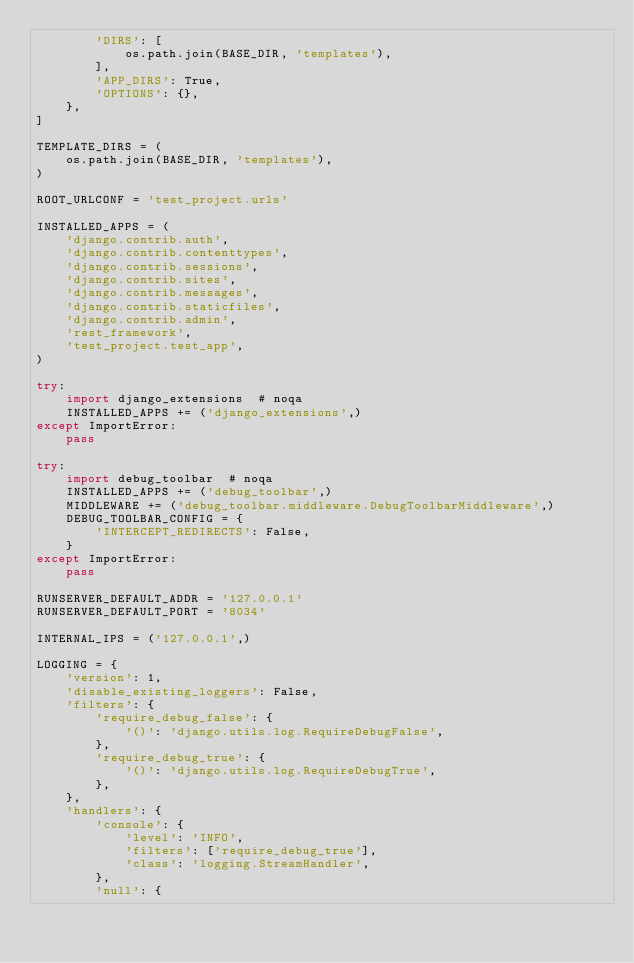Convert code to text. <code><loc_0><loc_0><loc_500><loc_500><_Python_>        'DIRS': [
            os.path.join(BASE_DIR, 'templates'),
        ],
        'APP_DIRS': True,
        'OPTIONS': {},
    },
]

TEMPLATE_DIRS = (
    os.path.join(BASE_DIR, 'templates'),
)

ROOT_URLCONF = 'test_project.urls'

INSTALLED_APPS = (
    'django.contrib.auth',
    'django.contrib.contenttypes',
    'django.contrib.sessions',
    'django.contrib.sites',
    'django.contrib.messages',
    'django.contrib.staticfiles',
    'django.contrib.admin',
    'rest_framework',
    'test_project.test_app',
)

try:
    import django_extensions  # noqa
    INSTALLED_APPS += ('django_extensions',)
except ImportError:
    pass

try:
    import debug_toolbar  # noqa
    INSTALLED_APPS += ('debug_toolbar',)
    MIDDLEWARE += ('debug_toolbar.middleware.DebugToolbarMiddleware',)
    DEBUG_TOOLBAR_CONFIG = {
        'INTERCEPT_REDIRECTS': False,
    }
except ImportError:
    pass

RUNSERVER_DEFAULT_ADDR = '127.0.0.1'
RUNSERVER_DEFAULT_PORT = '8034'

INTERNAL_IPS = ('127.0.0.1',)

LOGGING = {
    'version': 1,
    'disable_existing_loggers': False,
    'filters': {
        'require_debug_false': {
            '()': 'django.utils.log.RequireDebugFalse',
        },
        'require_debug_true': {
            '()': 'django.utils.log.RequireDebugTrue',
        },
    },
    'handlers': {
        'console': {
            'level': 'INFO',
            'filters': ['require_debug_true'],
            'class': 'logging.StreamHandler',
        },
        'null': {</code> 